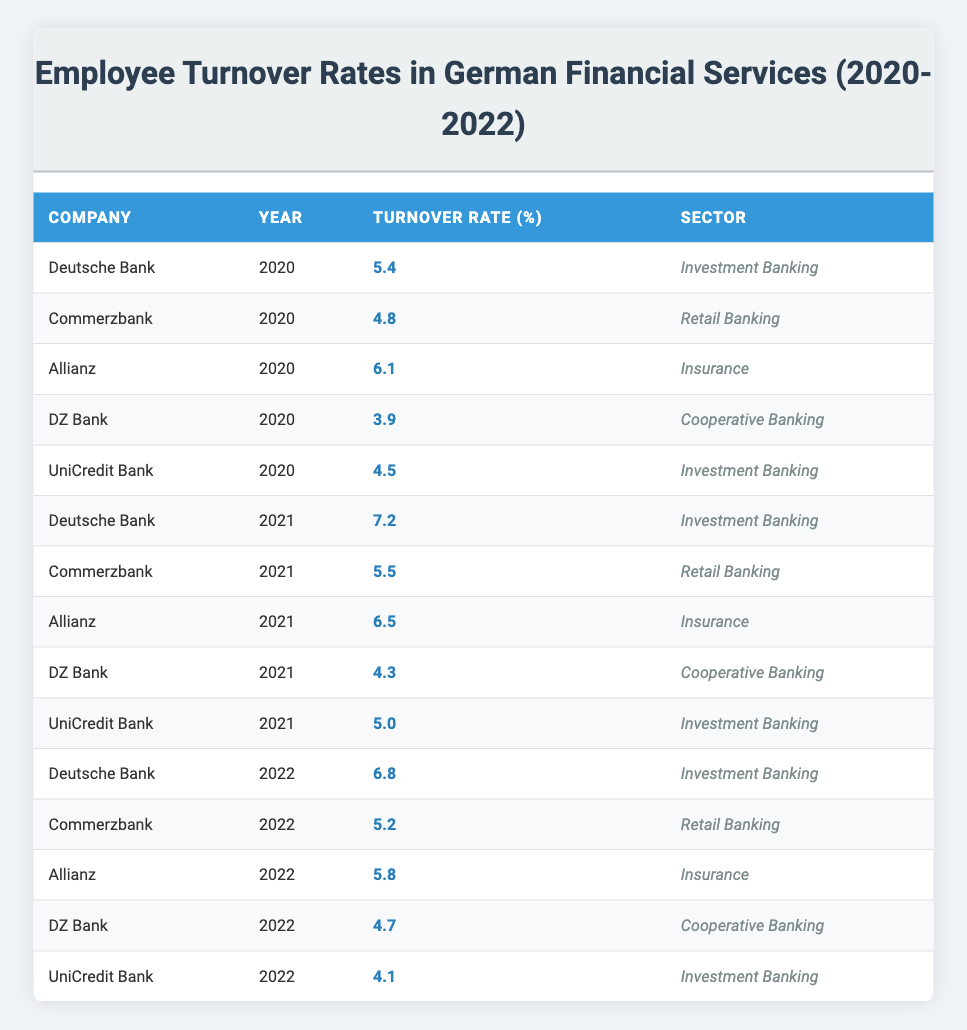What was the turnover rate for Allianz in 2021? In the table, I locate the row for Allianz under the year 2021, which shows a turnover rate of 6.5%.
Answer: 6.5 Which company had the highest turnover rate in 2022? I scan the table for the year 2022, comparing the turnover rates of all companies. Deutsche Bank has the highest turnover rate at 6.8%.
Answer: 6.8 What is the average turnover rate for Commerzbank from 2020 to 2022? I retrieve the turnover rates for Commerzbank: 4.8% in 2020, 5.5% in 2021, and 5.2% in 2022. The sum is (4.8 + 5.5 + 5.2) = 15.5% and dividing by 3 gives an average of 15.5 / 3 = 5.17%.
Answer: 5.17 Has the employee turnover rate for DZ Bank increased from 2020 to 2022? I look at the turnover rates for DZ Bank: 3.9% in 2020, 4.3% in 2021, and 4.7% in 2022. Since 3.9% is less than 4.3% and 4.3% is less than 4.7%, the turnover rate has indeed increased over these years.
Answer: Yes What was the difference in turnover rates between Deutsche Bank in 2021 and 2022? The turnover rate for Deutsche Bank was 7.2% in 2021 and 6.8% in 2022. To find the difference, I subtract 6.8 from 7.2, resulting in 7.2 - 6.8 = 0.4%.
Answer: 0.4 What sector had the highest turnover rate in 2020? Looking through the table for 2020, I identify the turnover rates for each sector: Investment Banking (5.4% for Deutsche Bank, 4.5% for UniCredit Bank), Retail Banking (4.8% for Commerzbank), Insurance (6.1% for Allianz), and Cooperative Banking (3.9% for DZ Bank). The Insurance sector has the highest turnover rate at 6.1%.
Answer: Insurance Is it true that UniCredit Bank's turnover rate decreased from 2021 to 2022? For UniCredit Bank, the turnover rates are 5.0% in 2021 and 4.1% in 2022. Since 4.1% is less than 5.0%, this indicates a decrease in the turnover rate.
Answer: Yes What was the total turnover rate for the Investment Banking sector over the three years? I extract the turnover rates for Investment Banking: 5.4% (2020), 7.2% (2021), and 6.8% (2022) from Deutsche Bank and UniCredit Bank (4.5%, 5.0%, 4.1% respectively). The total turnover rate combines both companies: (5.4 + 4.5) + (7.2 + 5.0) + (6.8 + 4.1) = 37.5%.
Answer: 37.5 